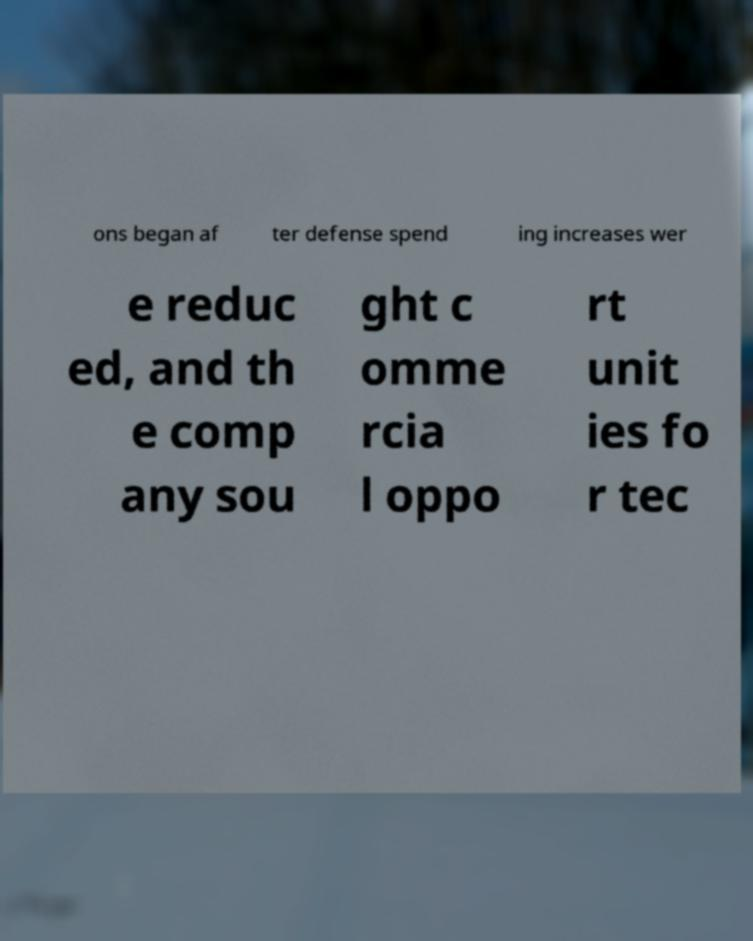I need the written content from this picture converted into text. Can you do that? ons began af ter defense spend ing increases wer e reduc ed, and th e comp any sou ght c omme rcia l oppo rt unit ies fo r tec 